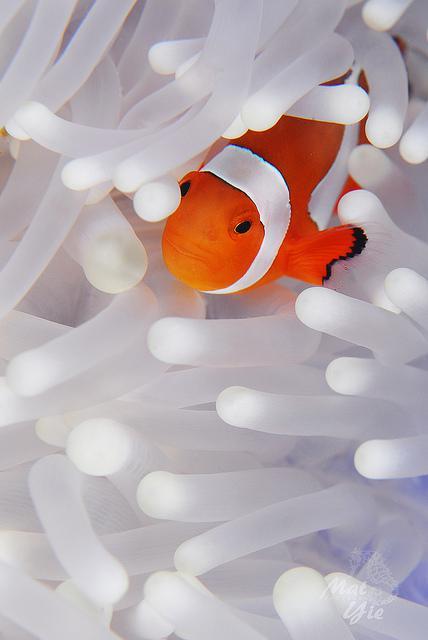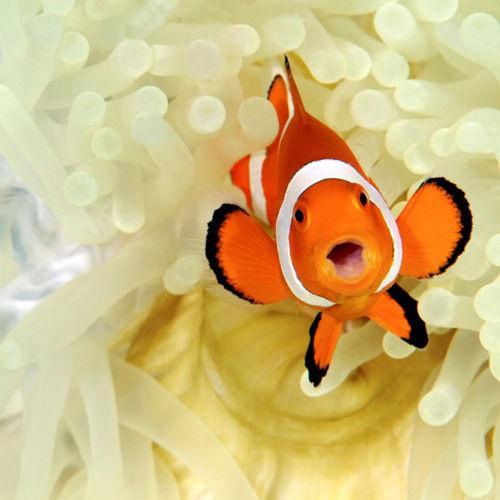The first image is the image on the left, the second image is the image on the right. For the images shown, is this caption "Each image shows one black-eyed clown fish within the white, slender tendrils of an anemone." true? Answer yes or no. Yes. The first image is the image on the left, the second image is the image on the right. For the images shown, is this caption "the left and right image contains the same number of dogs clownfish." true? Answer yes or no. Yes. 